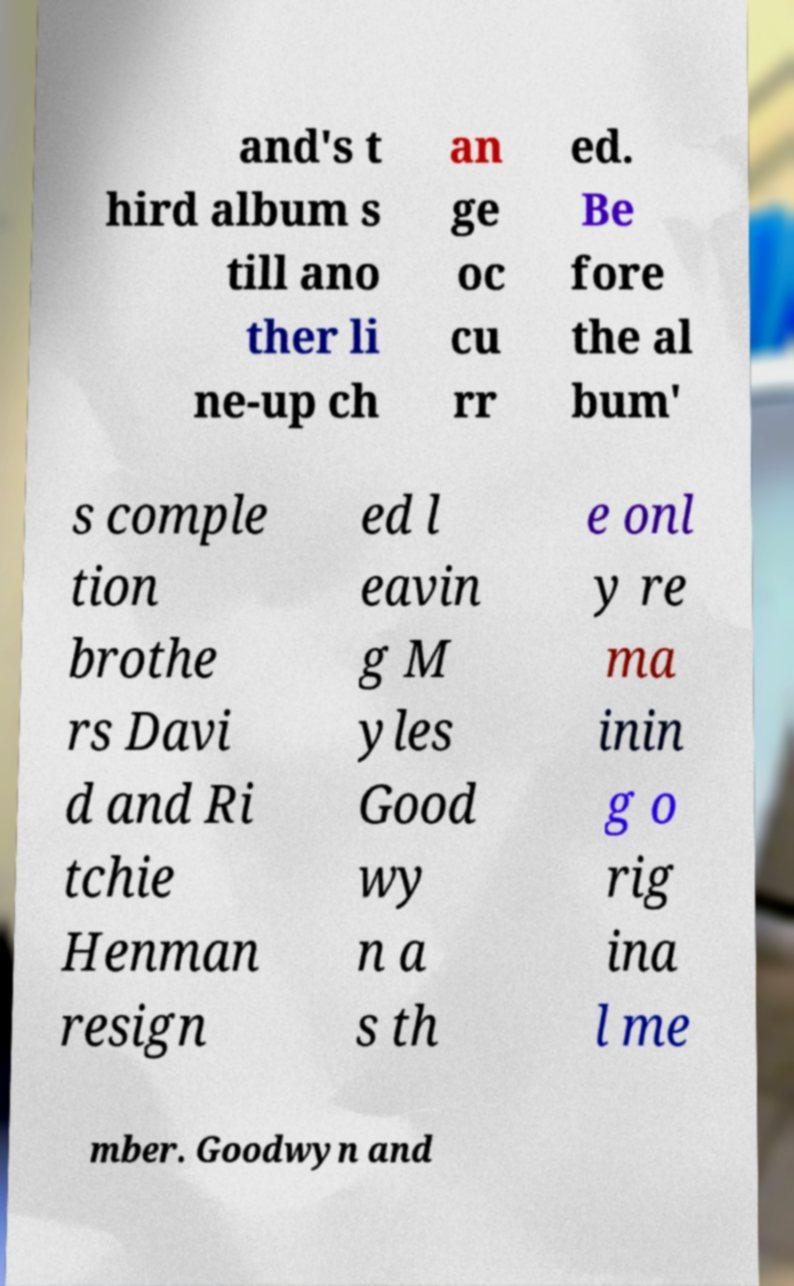What messages or text are displayed in this image? I need them in a readable, typed format. and's t hird album s till ano ther li ne-up ch an ge oc cu rr ed. Be fore the al bum' s comple tion brothe rs Davi d and Ri tchie Henman resign ed l eavin g M yles Good wy n a s th e onl y re ma inin g o rig ina l me mber. Goodwyn and 